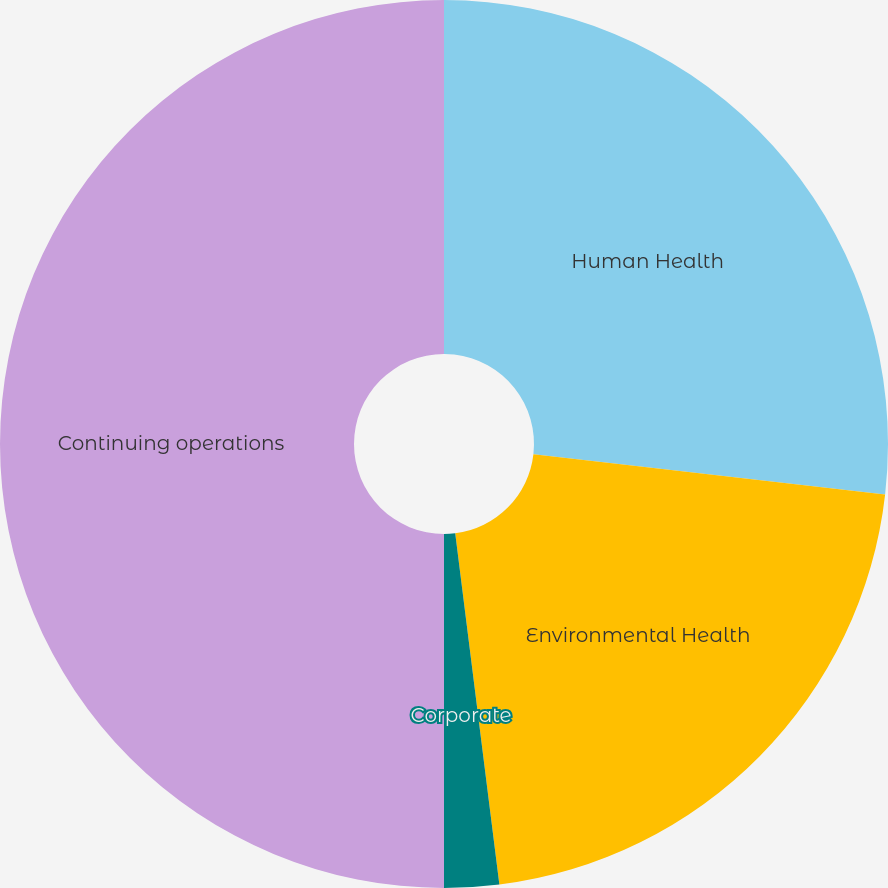Convert chart to OTSL. <chart><loc_0><loc_0><loc_500><loc_500><pie_chart><fcel>Human Health<fcel>Environmental Health<fcel>Corporate<fcel>Continuing operations<nl><fcel>26.81%<fcel>21.2%<fcel>1.99%<fcel>50.0%<nl></chart> 